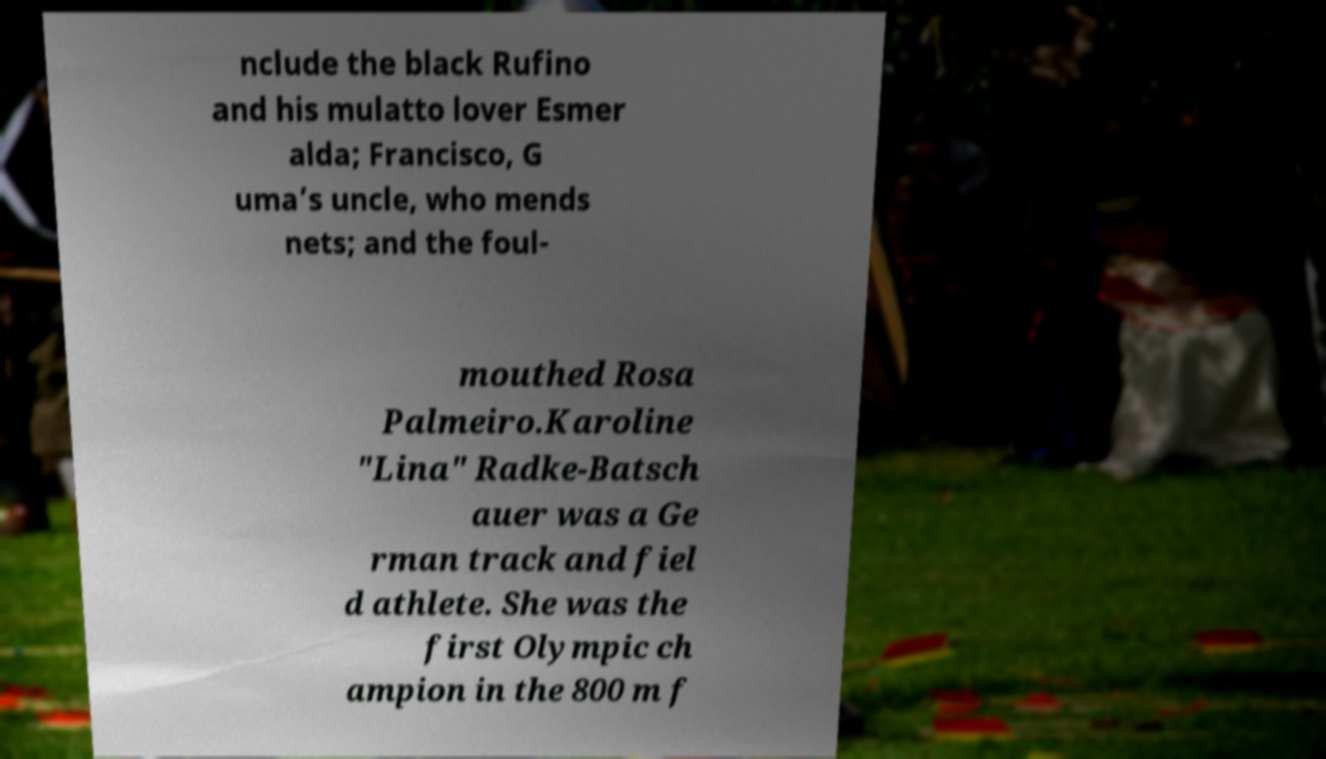Could you extract and type out the text from this image? nclude the black Rufino and his mulatto lover Esmer alda; Francisco, G uma’s uncle, who mends nets; and the foul- mouthed Rosa Palmeiro.Karoline "Lina" Radke-Batsch auer was a Ge rman track and fiel d athlete. She was the first Olympic ch ampion in the 800 m f 